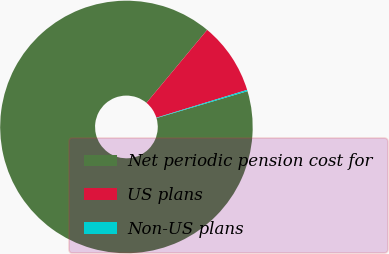Convert chart. <chart><loc_0><loc_0><loc_500><loc_500><pie_chart><fcel>Net periodic pension cost for<fcel>US plans<fcel>Non-US plans<nl><fcel>90.62%<fcel>9.21%<fcel>0.17%<nl></chart> 